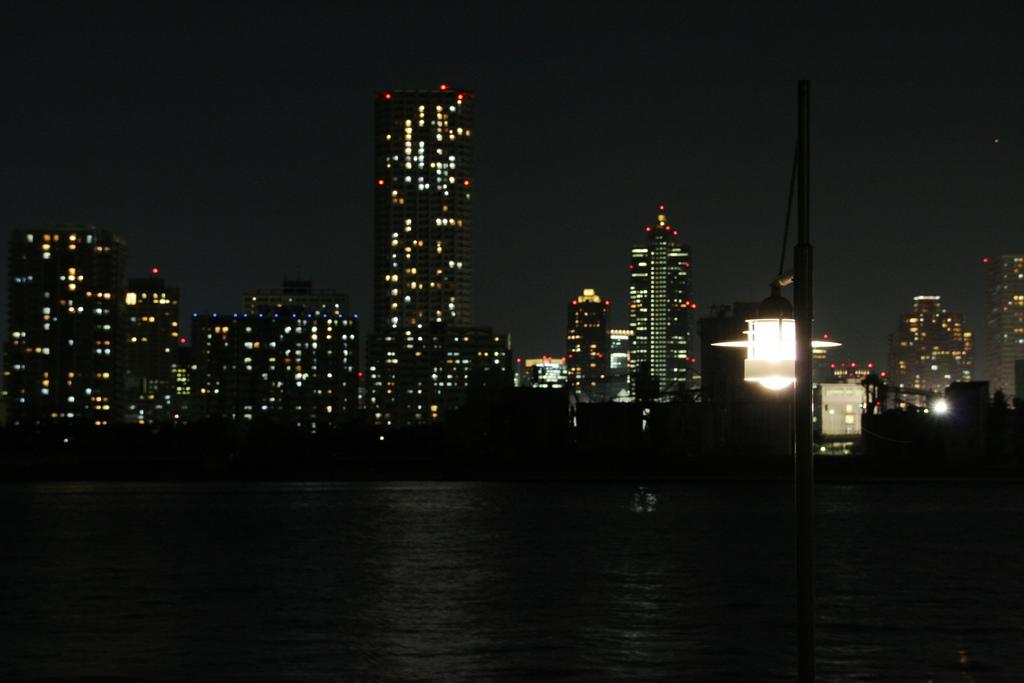What is the primary element visible in the image? There is water in the image. What structure can be seen in the image? There is a pole in the image. What is attached to the pole? There is a light in the image. What can be seen in the background of the image? There are buildings and lights in the background of the image, as well as the sky. Can you see a rail on which the water is sliding in the image? There is no rail present in the image, and the water is not sliding on any surface. 